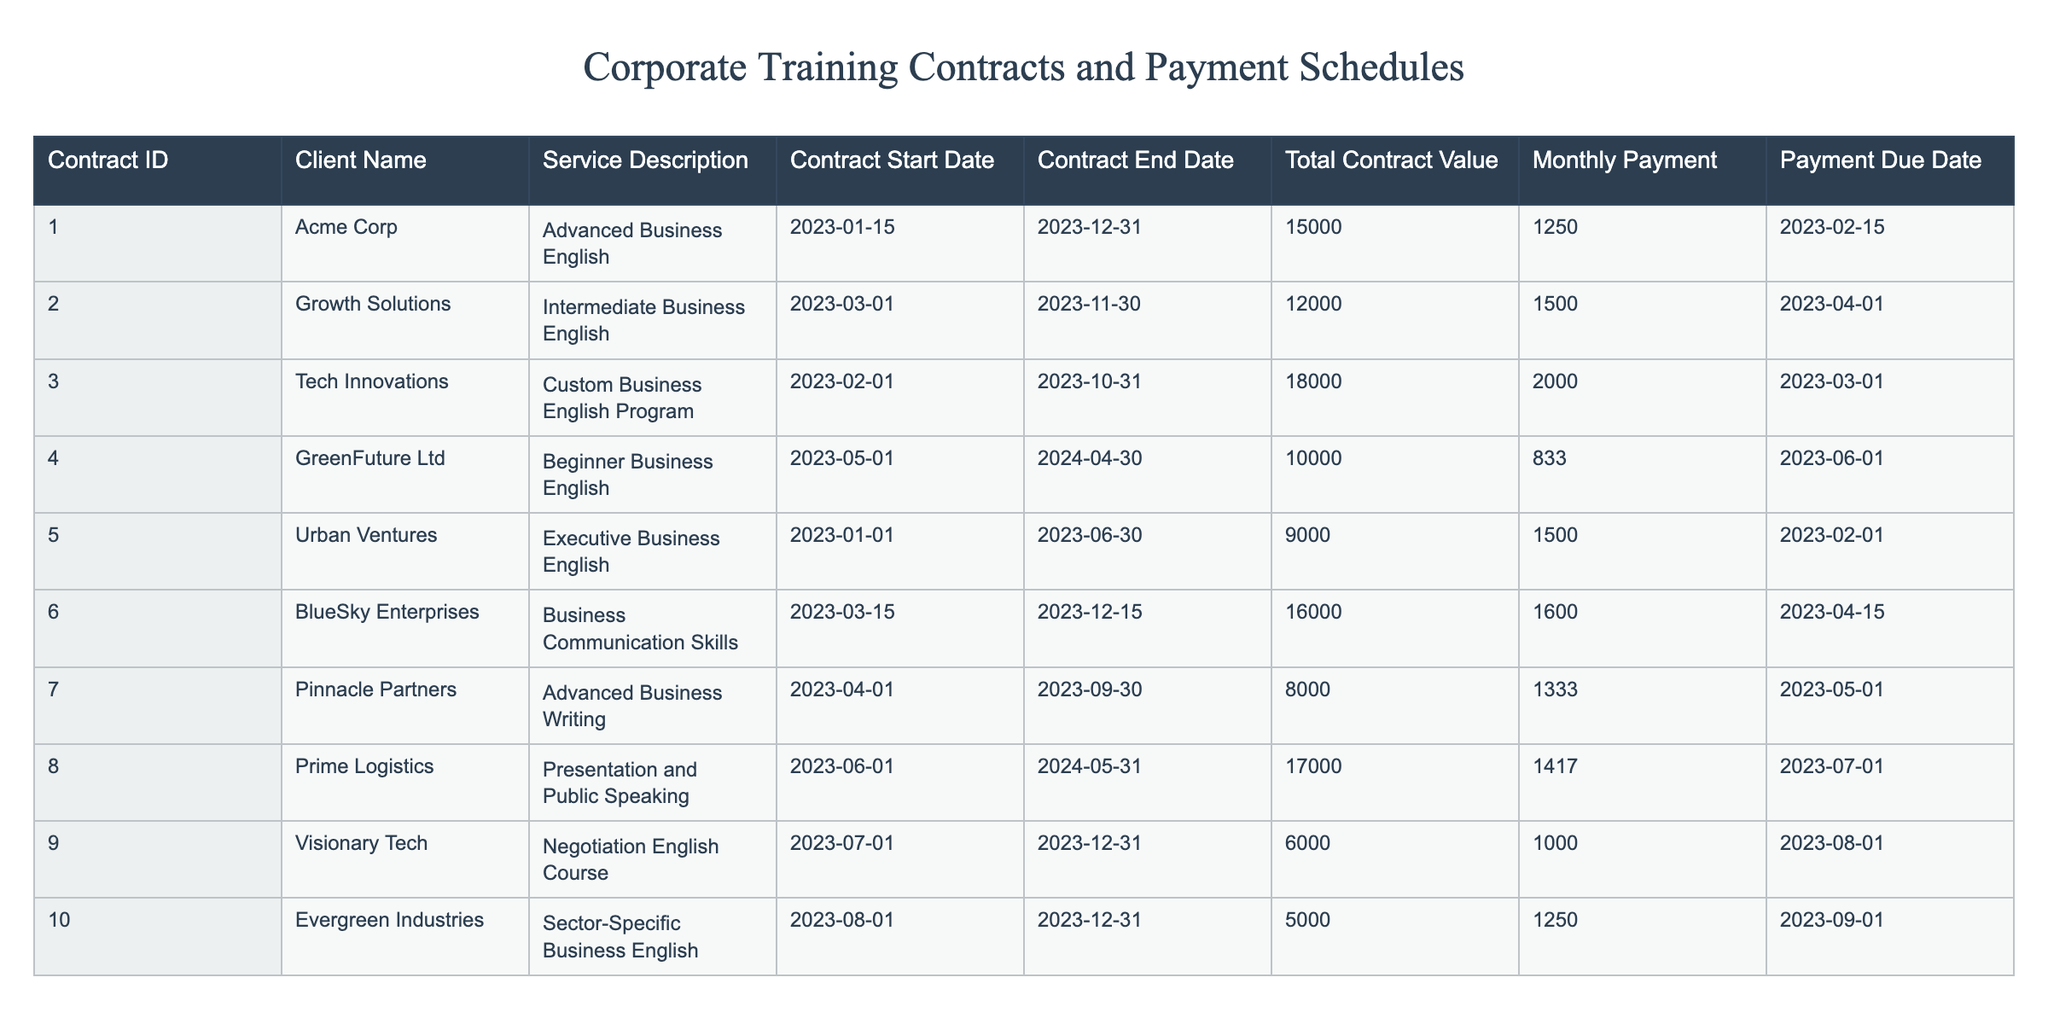What is the total contract value for Acme Corp? Acme Corp has a contract listed under Contract ID 001, which shows a Total Contract Value of 15000.
Answer: 15000 How many clients have a monthly payment of 1500? Referring to the Monthly Payment column, the clients with a payment of 1500 are Growth Solutions and Urban Ventures. Therefore, there are 2 clients.
Answer: 2 What is the average total contract value for all clients? The total contract values are 15000, 12000, 18000, 10000, 9000, 16000, 8000, 17000, 6000, and 5000. Summing these gives 15000 + 12000 + 18000 + 10000 + 9000 + 16000 + 8000 + 17000 + 6000 + 5000 = 126000. Since there are 10 contracts, the average is 126000 / 10 = 12600.
Answer: 12600 Is there a contract for BlueSky Enterprises that ends after January 2024? BlueSky Enterprises has a contract that ends on December 15, 2023. Since this is before January 2024, the answer is no.
Answer: No Which client has the earliest contract start date, and what is that date? The contracts start on the following dates: Acme Corp (2023-01-15), Urban Ventures (2023-01-01), Tech Innovations (2023-02-01), and so on. Urban Ventures has the earliest start date of 2023-01-01.
Answer: 2023-01-01 How many contracts have a payment due date in July 2023? Checking the Payment Due Dates, there are two entries for July: Prime Logistics has 2023-07-01 and Visionary Tech has 2023-08-01. Therefore, only 1 contract is due in July 2023.
Answer: 1 What is the total amount of monthly payments due for all contracts? The monthly payments are: 1250, 1500, 2000, 833, 1500, 1600, 1333, 1417, 1000, and 1250. Adding these amounts gives a total of 1250 + 1500 + 2000 + 833 + 1500 + 1600 + 1333 + 1417 + 1000 + 1250 = 13683.
Answer: 13683 Does any client have a contract value below 7000? The lowest contract value from the table is 5000 from Evergreen Industries, which is below 7000. Therefore, yes, there is a client with a contract value below 7000.
Answer: Yes Which contract has the highest monthly payment, and what is that amount? Looking through the Monthly Payment amounts, the highest payment is 2000 from the contract for Tech Innovations.
Answer: 2000 